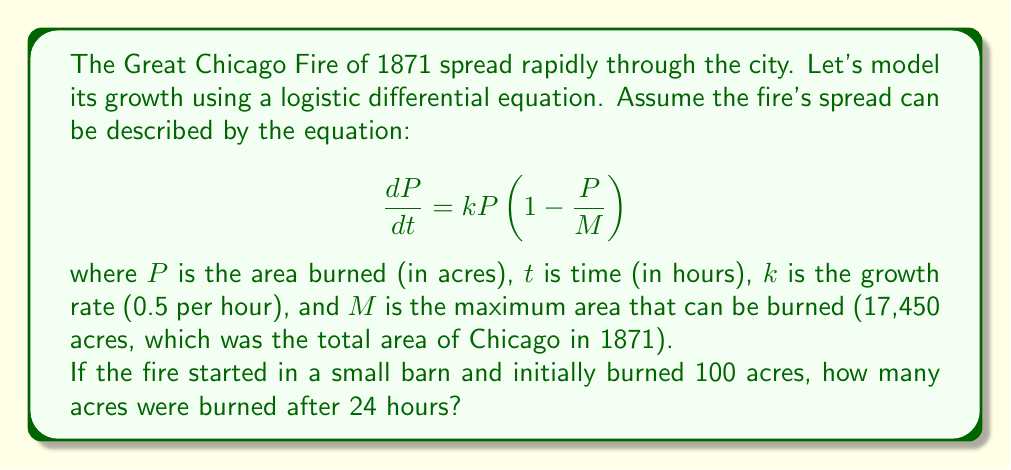Provide a solution to this math problem. Let's approach this step-by-step:

1) The logistic differential equation is given by:

   $$\frac{dP}{dt} = kP(1-\frac{P}{M})$$

2) We're given:
   - $k = 0.5$ per hour
   - $M = 17,450$ acres
   - Initial condition: $P(0) = 100$ acres
   - We need to find $P(24)$

3) The solution to this logistic equation is:

   $$P(t) = \frac{MP_0}{P_0 + (M-P_0)e^{-kt}}$$

   Where $P_0$ is the initial value of $P$.

4) Substituting our values:

   $$P(t) = \frac{17450 \cdot 100}{100 + (17450-100)e^{-0.5t}}$$

5) Simplify:

   $$P(t) = \frac{1745000}{100 + 17350e^{-0.5t}}$$

6) Now, we need to find $P(24)$:

   $$P(24) = \frac{1745000}{100 + 17350e^{-0.5(24)}}$$

7) Calculate:
   
   $$P(24) = \frac{1745000}{100 + 17350e^{-12}} \approx 16726.8$$

8) Round to the nearest acre:

   $P(24) \approx 16727$ acres
Answer: After 24 hours, approximately 16,727 acres were burned in the Great Chicago Fire of 1871, according to this logistic growth model. 